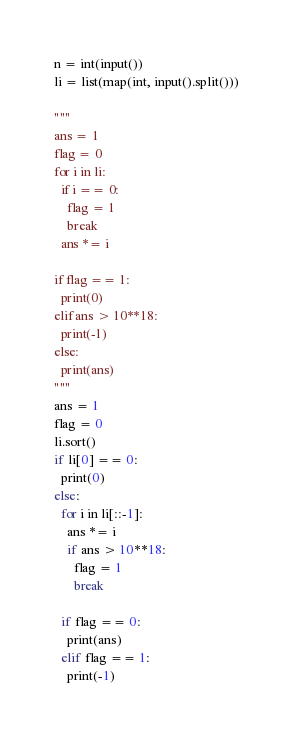<code> <loc_0><loc_0><loc_500><loc_500><_Python_>n = int(input())
li = list(map(int, input().split()))

"""
ans = 1
flag = 0
for i in li:
  if i == 0:
    flag = 1
    break
  ans *= i

if flag == 1:
  print(0)
elif ans > 10**18:
  print(-1)
else:
  print(ans)
"""
ans = 1
flag = 0
li.sort()
if li[0] == 0:
  print(0)
else:
  for i in li[::-1]:
    ans *= i
    if ans > 10**18:
      flag = 1
      break

  if flag == 0:
    print(ans)
  elif flag == 1:
    print(-1)</code> 